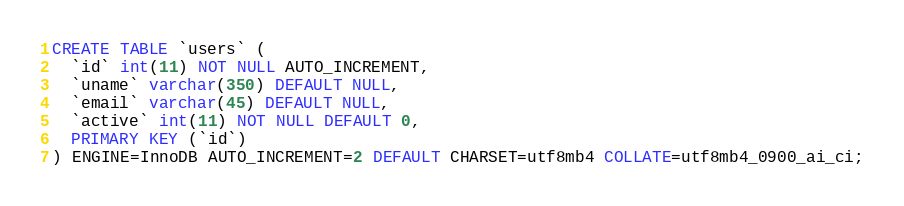<code> <loc_0><loc_0><loc_500><loc_500><_SQL_>CREATE TABLE `users` (
  `id` int(11) NOT NULL AUTO_INCREMENT,
  `uname` varchar(350) DEFAULT NULL,
  `email` varchar(45) DEFAULT NULL,
  `active` int(11) NOT NULL DEFAULT 0,
  PRIMARY KEY (`id`)
) ENGINE=InnoDB AUTO_INCREMENT=2 DEFAULT CHARSET=utf8mb4 COLLATE=utf8mb4_0900_ai_ci;</code> 